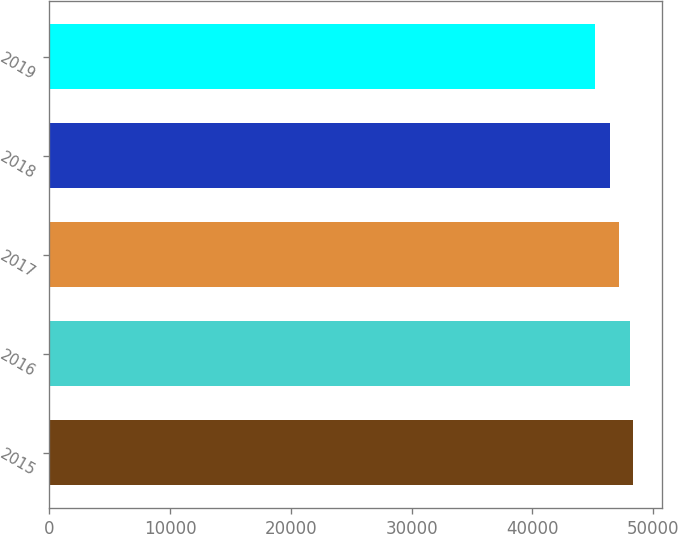Convert chart to OTSL. <chart><loc_0><loc_0><loc_500><loc_500><bar_chart><fcel>2015<fcel>2016<fcel>2017<fcel>2018<fcel>2019<nl><fcel>48344.1<fcel>48040<fcel>47192<fcel>46389<fcel>45189<nl></chart> 